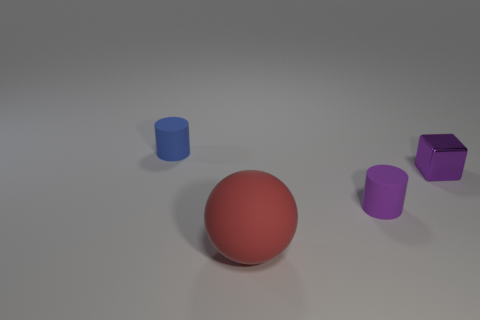Are there any other things that have the same material as the small purple cube?
Offer a very short reply. No. What shape is the other tiny thing that is the same color as the tiny metal thing?
Provide a short and direct response. Cylinder. Is there a small cylinder that has the same color as the metallic block?
Your answer should be very brief. Yes. How many things are matte balls or rubber things that are in front of the tiny block?
Your answer should be compact. 2. Are there more big red rubber spheres than small rubber balls?
Offer a very short reply. Yes. The matte thing that is the same color as the metal thing is what size?
Your answer should be compact. Small. Is there a blue thing made of the same material as the large red object?
Give a very brief answer. Yes. There is a tiny thing that is both on the left side of the tiny metallic cube and right of the blue thing; what shape is it?
Offer a very short reply. Cylinder. How many other things are the same shape as the small blue object?
Your response must be concise. 1. The purple metallic object is what size?
Offer a terse response. Small. 